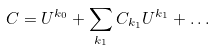<formula> <loc_0><loc_0><loc_500><loc_500>C = U ^ { { k } _ { 0 } } + \sum _ { { k } _ { 1 } } C _ { { k } _ { 1 } } U ^ { { k } _ { 1 } } + \dots</formula> 